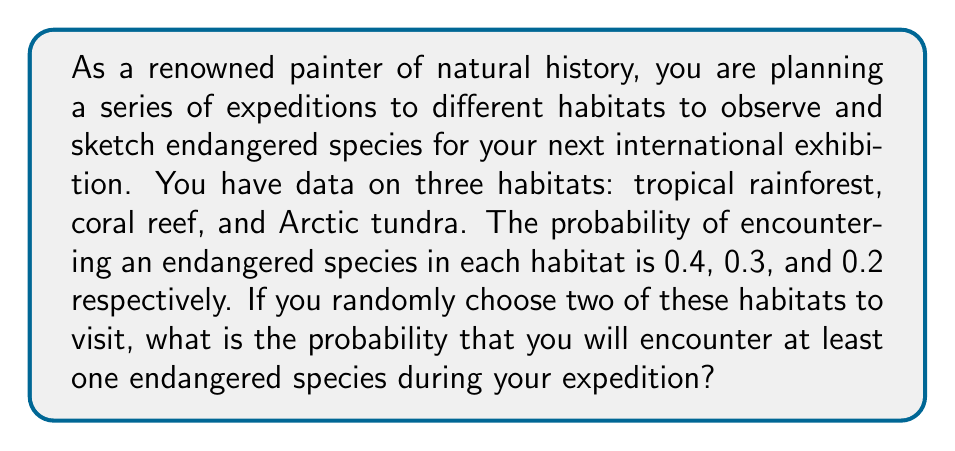Can you answer this question? Let's approach this step-by-step:

1) First, we need to calculate the probability of not encountering an endangered species in each habitat:
   Tropical rainforest: $1 - 0.4 = 0.6$
   Coral reef: $1 - 0.3 = 0.7$
   Arctic tundra: $1 - 0.2 = 0.8$

2) Now, we need to consider all possible combinations of two habitats:
   - Tropical rainforest and Coral reef
   - Tropical rainforest and Arctic tundra
   - Coral reef and Arctic tundra

3) For each combination, we calculate the probability of not encountering an endangered species in either habitat:
   - Tropical rainforest and Coral reef: $0.6 \times 0.7 = 0.42$
   - Tropical rainforest and Arctic tundra: $0.6 \times 0.8 = 0.48$
   - Coral reef and Arctic tundra: $0.7 \times 0.8 = 0.56$

4) The probability of choosing each combination is equal (1/3), so we can calculate the overall probability of not encountering an endangered species:

   $$P(\text{no encounter}) = \frac{1}{3}(0.42 + 0.48 + 0.56) = 0.4867$$

5) Therefore, the probability of encountering at least one endangered species is:

   $$P(\text{at least one encounter}) = 1 - P(\text{no encounter}) = 1 - 0.4867 = 0.5133$$
Answer: 0.5133 